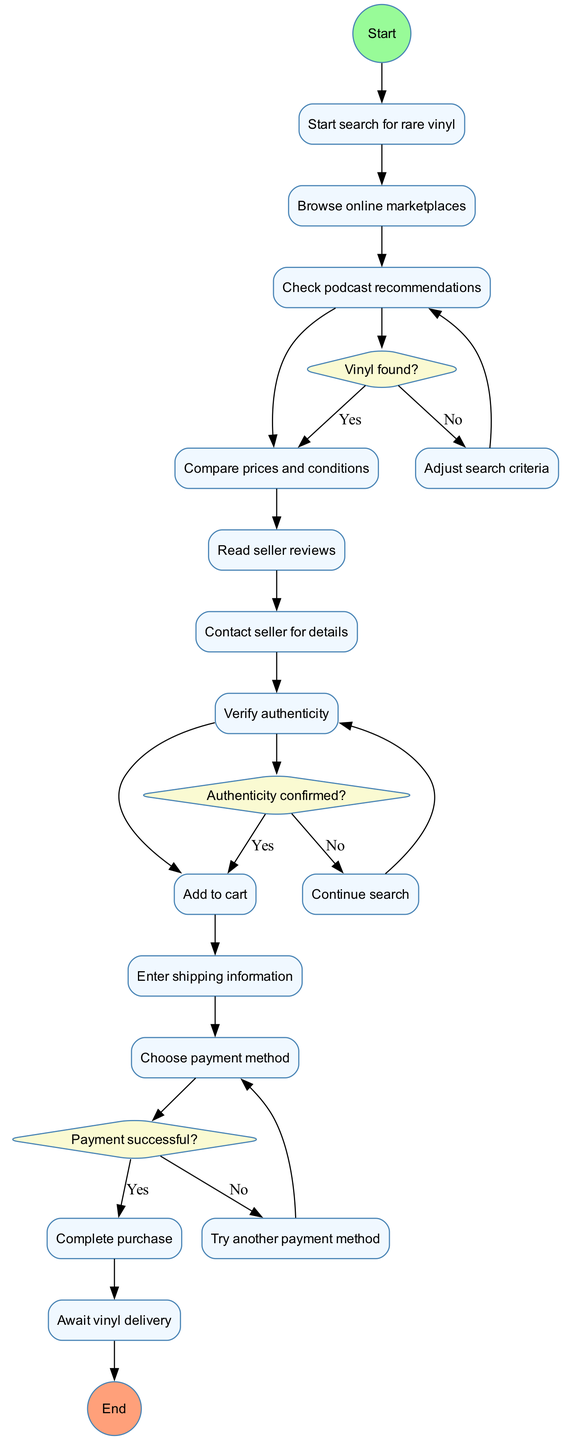What is the initial activity in the diagram? The diagram starts with the "Start search for rare vinyl" node, which leads directly to the first activity.
Answer: Start search for rare vinyl How many activities are listed in the diagram? Counting all the activities provided, there are 9 activities listed in total in the diagram.
Answer: 9 What happens if the vinyl is not found? If the vinyl is not found, the flow leads to "Adjust search criteria" as per the decision node labeled "Vinyl found?".
Answer: Adjust search criteria What is the final step in the purchasing process? The final step in the process is shown in the last node before the end which indicates that the user is waiting for the delivery of the vinyl.
Answer: Await vinyl delivery What decision leads to "Add to cart"? The decision leading to "Add to cart" occurs if the seller's authenticity is confirmed as indicated by the decision node "Authenticity confirmed?"
Answer: Authenticity confirmed What is the relationship between "Enter shipping information" and "Complete purchase"? "Enter shipping information" must occur before "Complete purchase" as indicated by the sequential flow in the diagram that connects these activities.
Answer: Sequential flow How many decision nodes are in the diagram? There are 3 decision nodes included in the diagram that represent points where a yes or no decision must be made.
Answer: 3 What activity follows after "Contact seller for details"? After "Contact seller for details," the flow moves to "Verify authenticity," making it the activity that directly follows.
Answer: Verify authenticity What is the question at the second decision node? The second decision node's question is "Authenticity confirmed?" which checks the authenticity of the vinyl record.
Answer: Authenticity confirmed? 